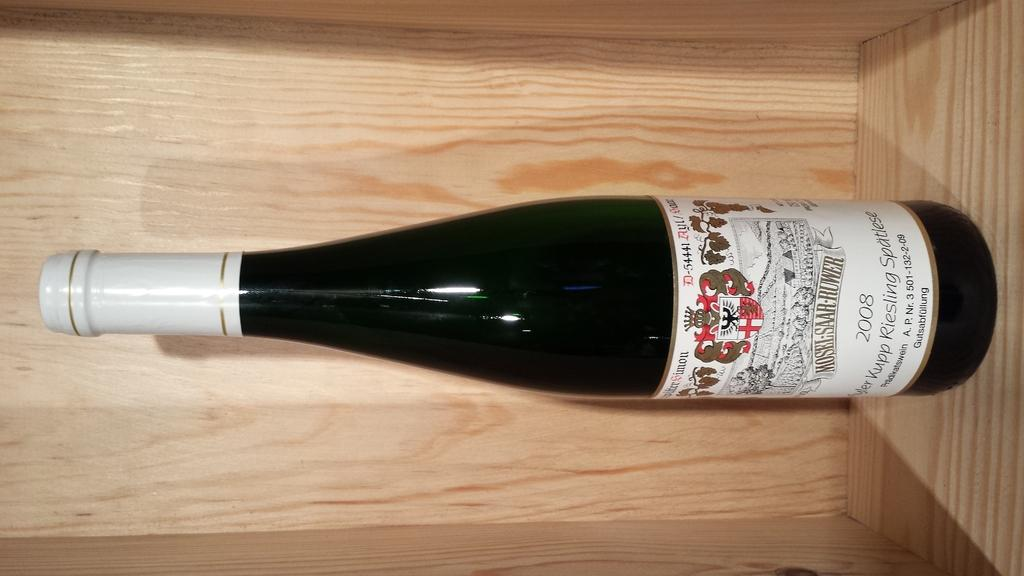Provide a one-sentence caption for the provided image. A bottle of 2008 Riesling wine by Mosel-Saar-Ruwer. 